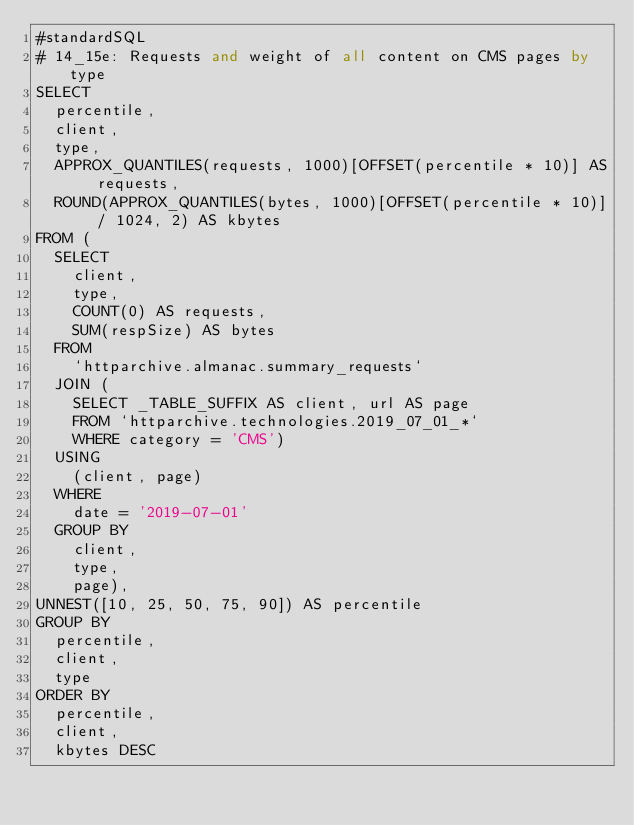<code> <loc_0><loc_0><loc_500><loc_500><_SQL_>#standardSQL
# 14_15e: Requests and weight of all content on CMS pages by type
SELECT
  percentile,
  client,
  type,
  APPROX_QUANTILES(requests, 1000)[OFFSET(percentile * 10)] AS requests,
  ROUND(APPROX_QUANTILES(bytes, 1000)[OFFSET(percentile * 10)] / 1024, 2) AS kbytes
FROM (
  SELECT
    client,
    type,
    COUNT(0) AS requests,
    SUM(respSize) AS bytes
  FROM
    `httparchive.almanac.summary_requests`
  JOIN (
    SELECT _TABLE_SUFFIX AS client, url AS page
    FROM `httparchive.technologies.2019_07_01_*`
    WHERE category = 'CMS')
  USING
    (client, page)
  WHERE
    date = '2019-07-01'
  GROUP BY
    client,
    type,
    page),
UNNEST([10, 25, 50, 75, 90]) AS percentile
GROUP BY
  percentile,
  client,
  type
ORDER BY
  percentile,
  client,
  kbytes DESC
</code> 